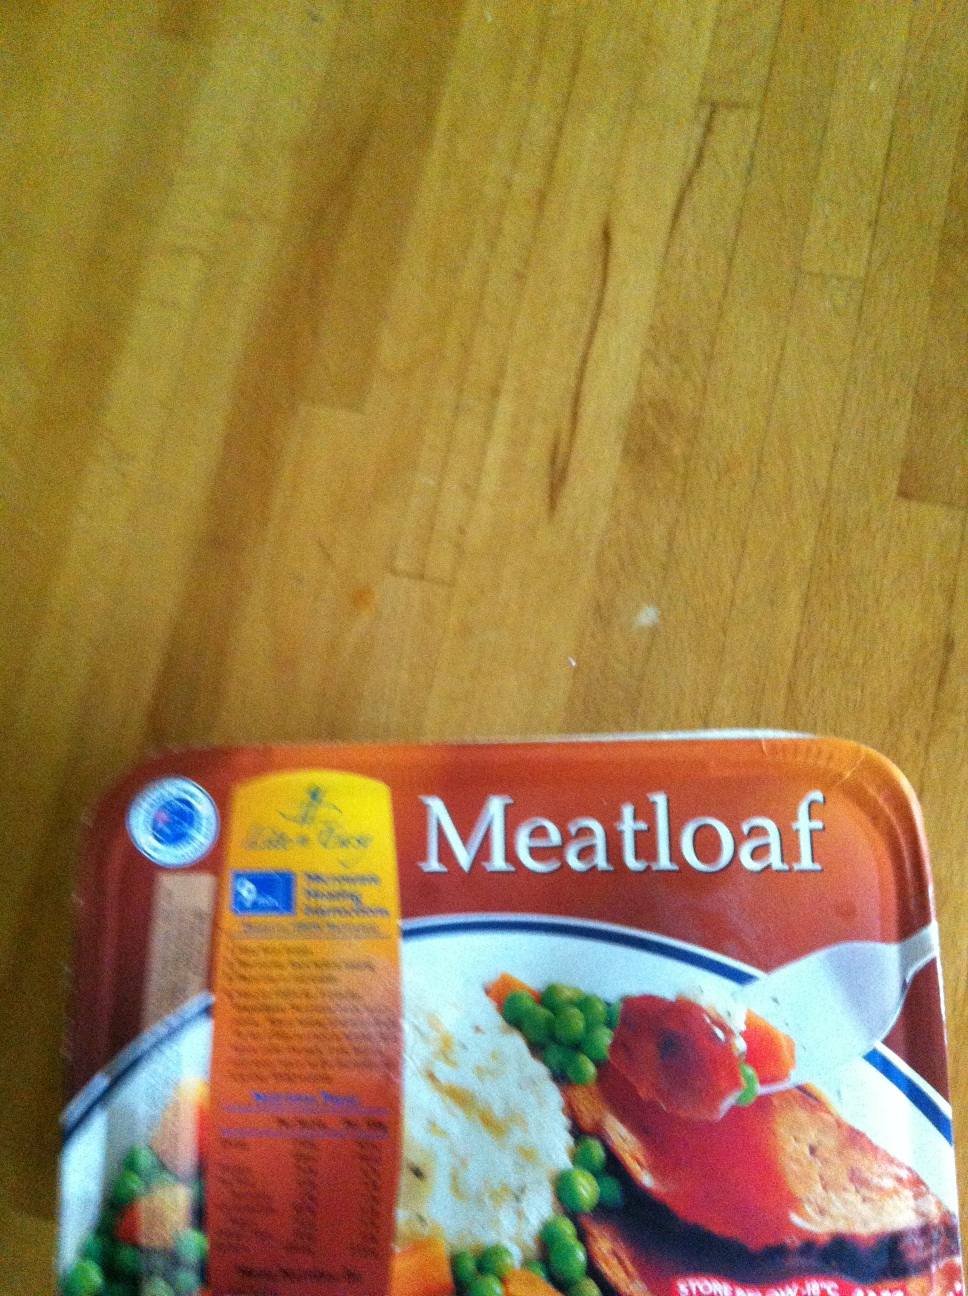Imagine you were hosting a dinner party; how could you creatively present this meatloaf? Hosting a dinner party with meatloaf can be quite elegant if done creatively. Slice the meatloaf into even servings and arrange them neatly on a large serving platter. Surround the slices with an array of colorful vegetables, such as roasted carrots, green beans, and cherry tomatoes, to enhance the visual appeal. Drizzle a delicious homemade gravy over the slices and garnish with freshly chopped herbs like parsley or rosemary for an aromatic touch. You could also serve it alongside creamy mashed potatoes swirled with butter, adding a sprinkle of paprika or black pepper for a gourmet finish. 